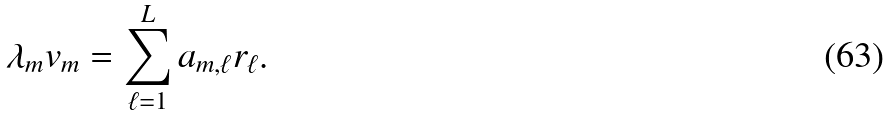Convert formula to latex. <formula><loc_0><loc_0><loc_500><loc_500>\lambda _ { m } v _ { m } = \sum _ { \ell = 1 } ^ { L } a _ { m , \ell } r _ { \ell } .</formula> 